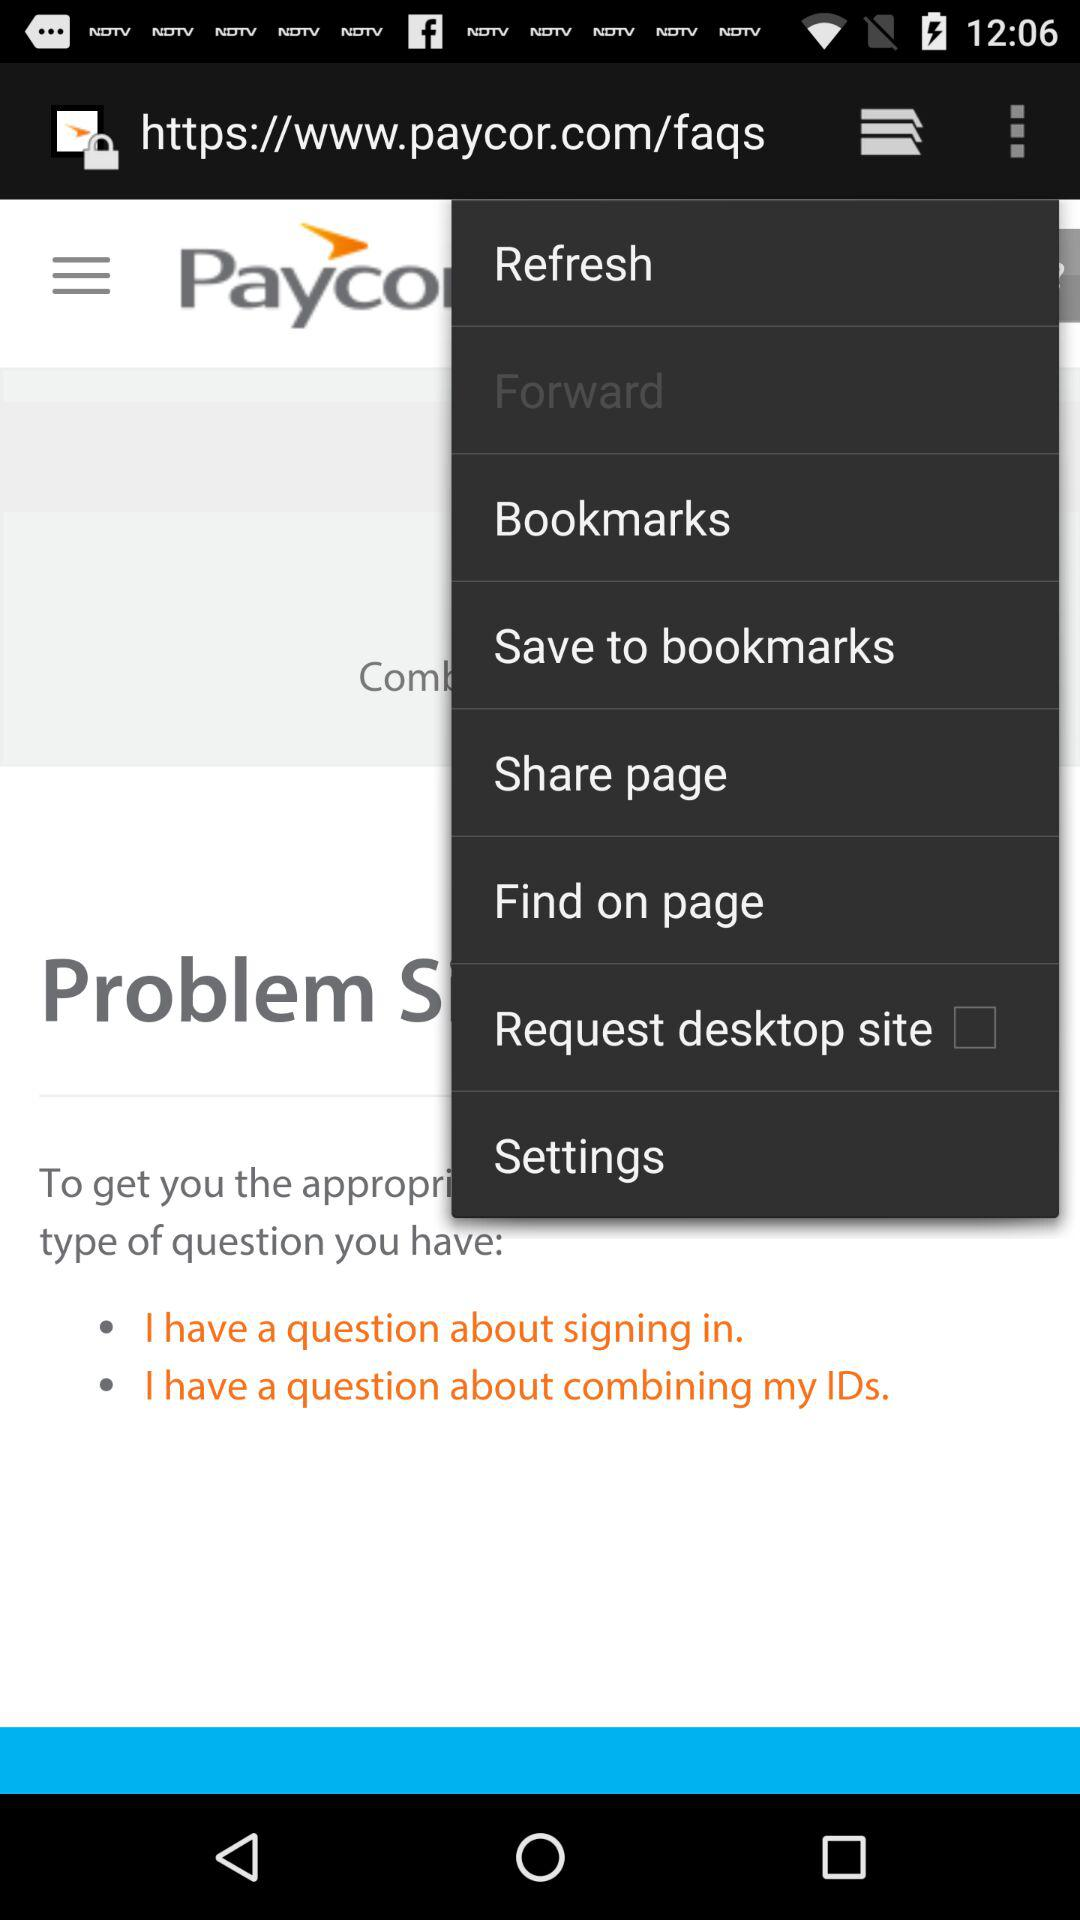What is the status of "Request desktop site"? The status is "off". 